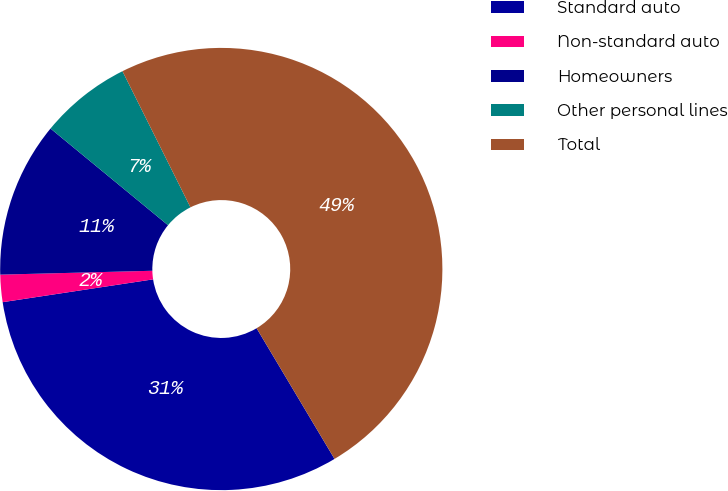<chart> <loc_0><loc_0><loc_500><loc_500><pie_chart><fcel>Standard auto<fcel>Non-standard auto<fcel>Homeowners<fcel>Other personal lines<fcel>Total<nl><fcel>31.16%<fcel>1.99%<fcel>11.36%<fcel>6.67%<fcel>48.81%<nl></chart> 